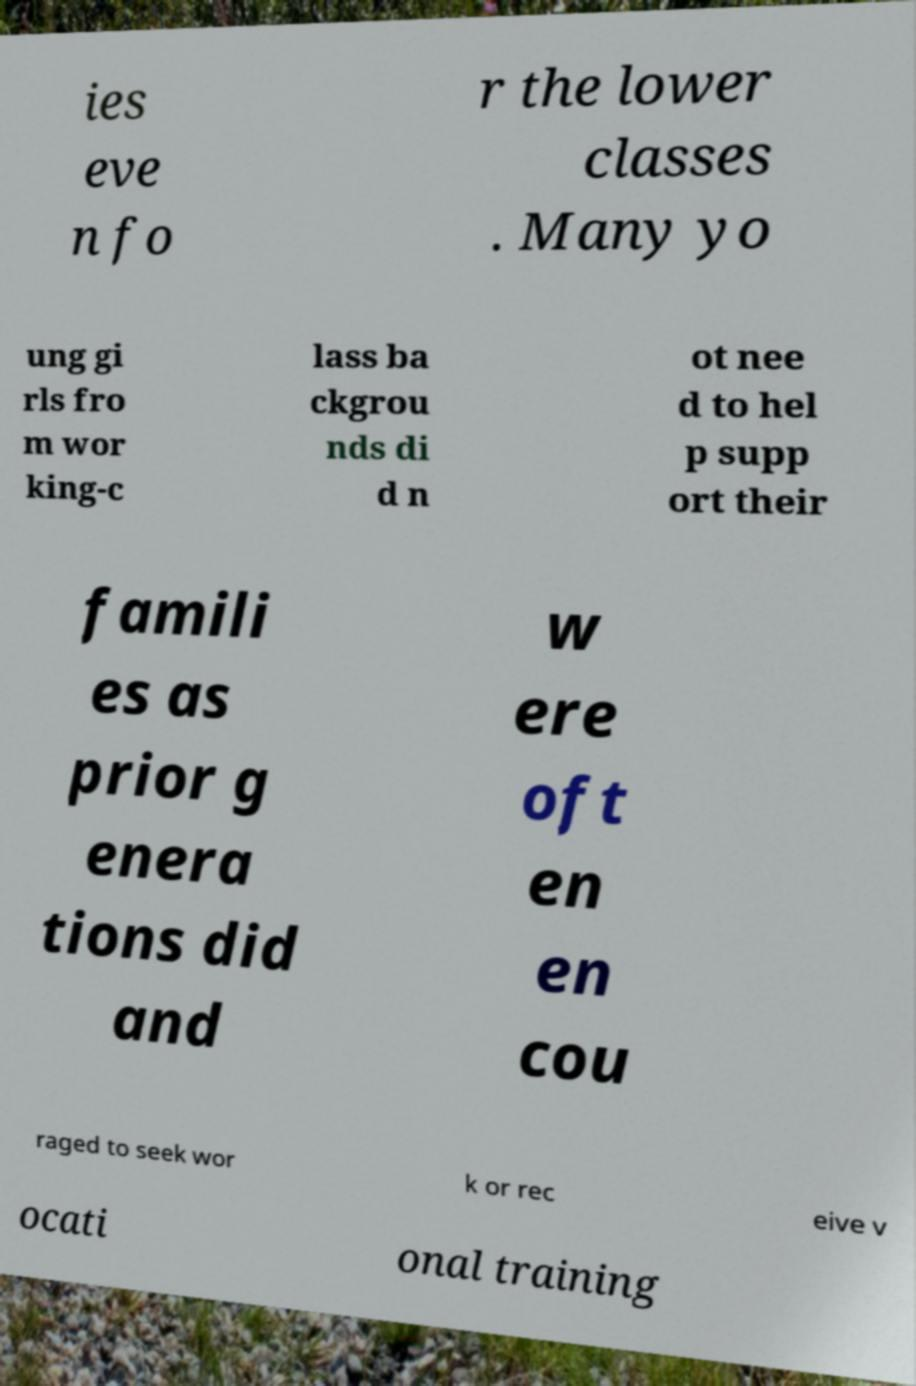There's text embedded in this image that I need extracted. Can you transcribe it verbatim? ies eve n fo r the lower classes . Many yo ung gi rls fro m wor king-c lass ba ckgrou nds di d n ot nee d to hel p supp ort their famili es as prior g enera tions did and w ere oft en en cou raged to seek wor k or rec eive v ocati onal training 